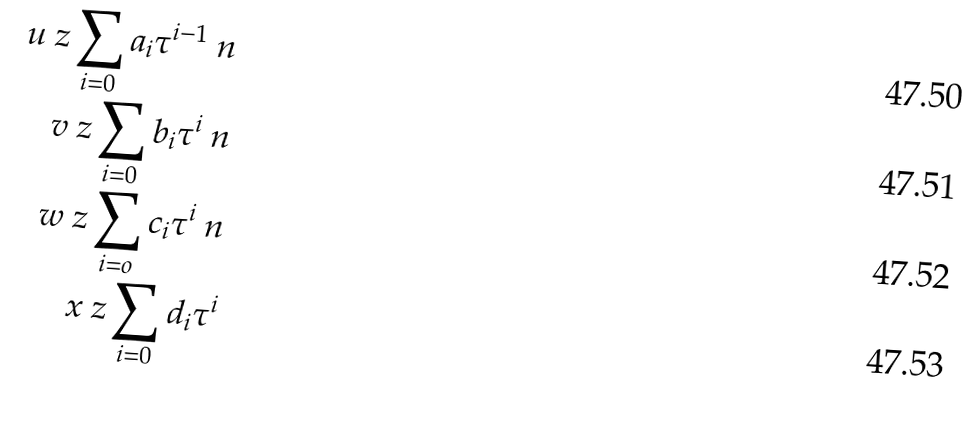<formula> <loc_0><loc_0><loc_500><loc_500>u \ z \sum _ { i = 0 } a _ { i } \tau ^ { i - 1 } \ n \\ v \ z \sum _ { i = 0 } b _ { i } \tau ^ { i } \ n \\ w \ z \sum _ { i = o } c _ { i } \tau ^ { i } \ n \\ x \ z \sum _ { i = 0 } d _ { i } \tau ^ { i }</formula> 